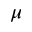<formula> <loc_0><loc_0><loc_500><loc_500>\mu</formula> 